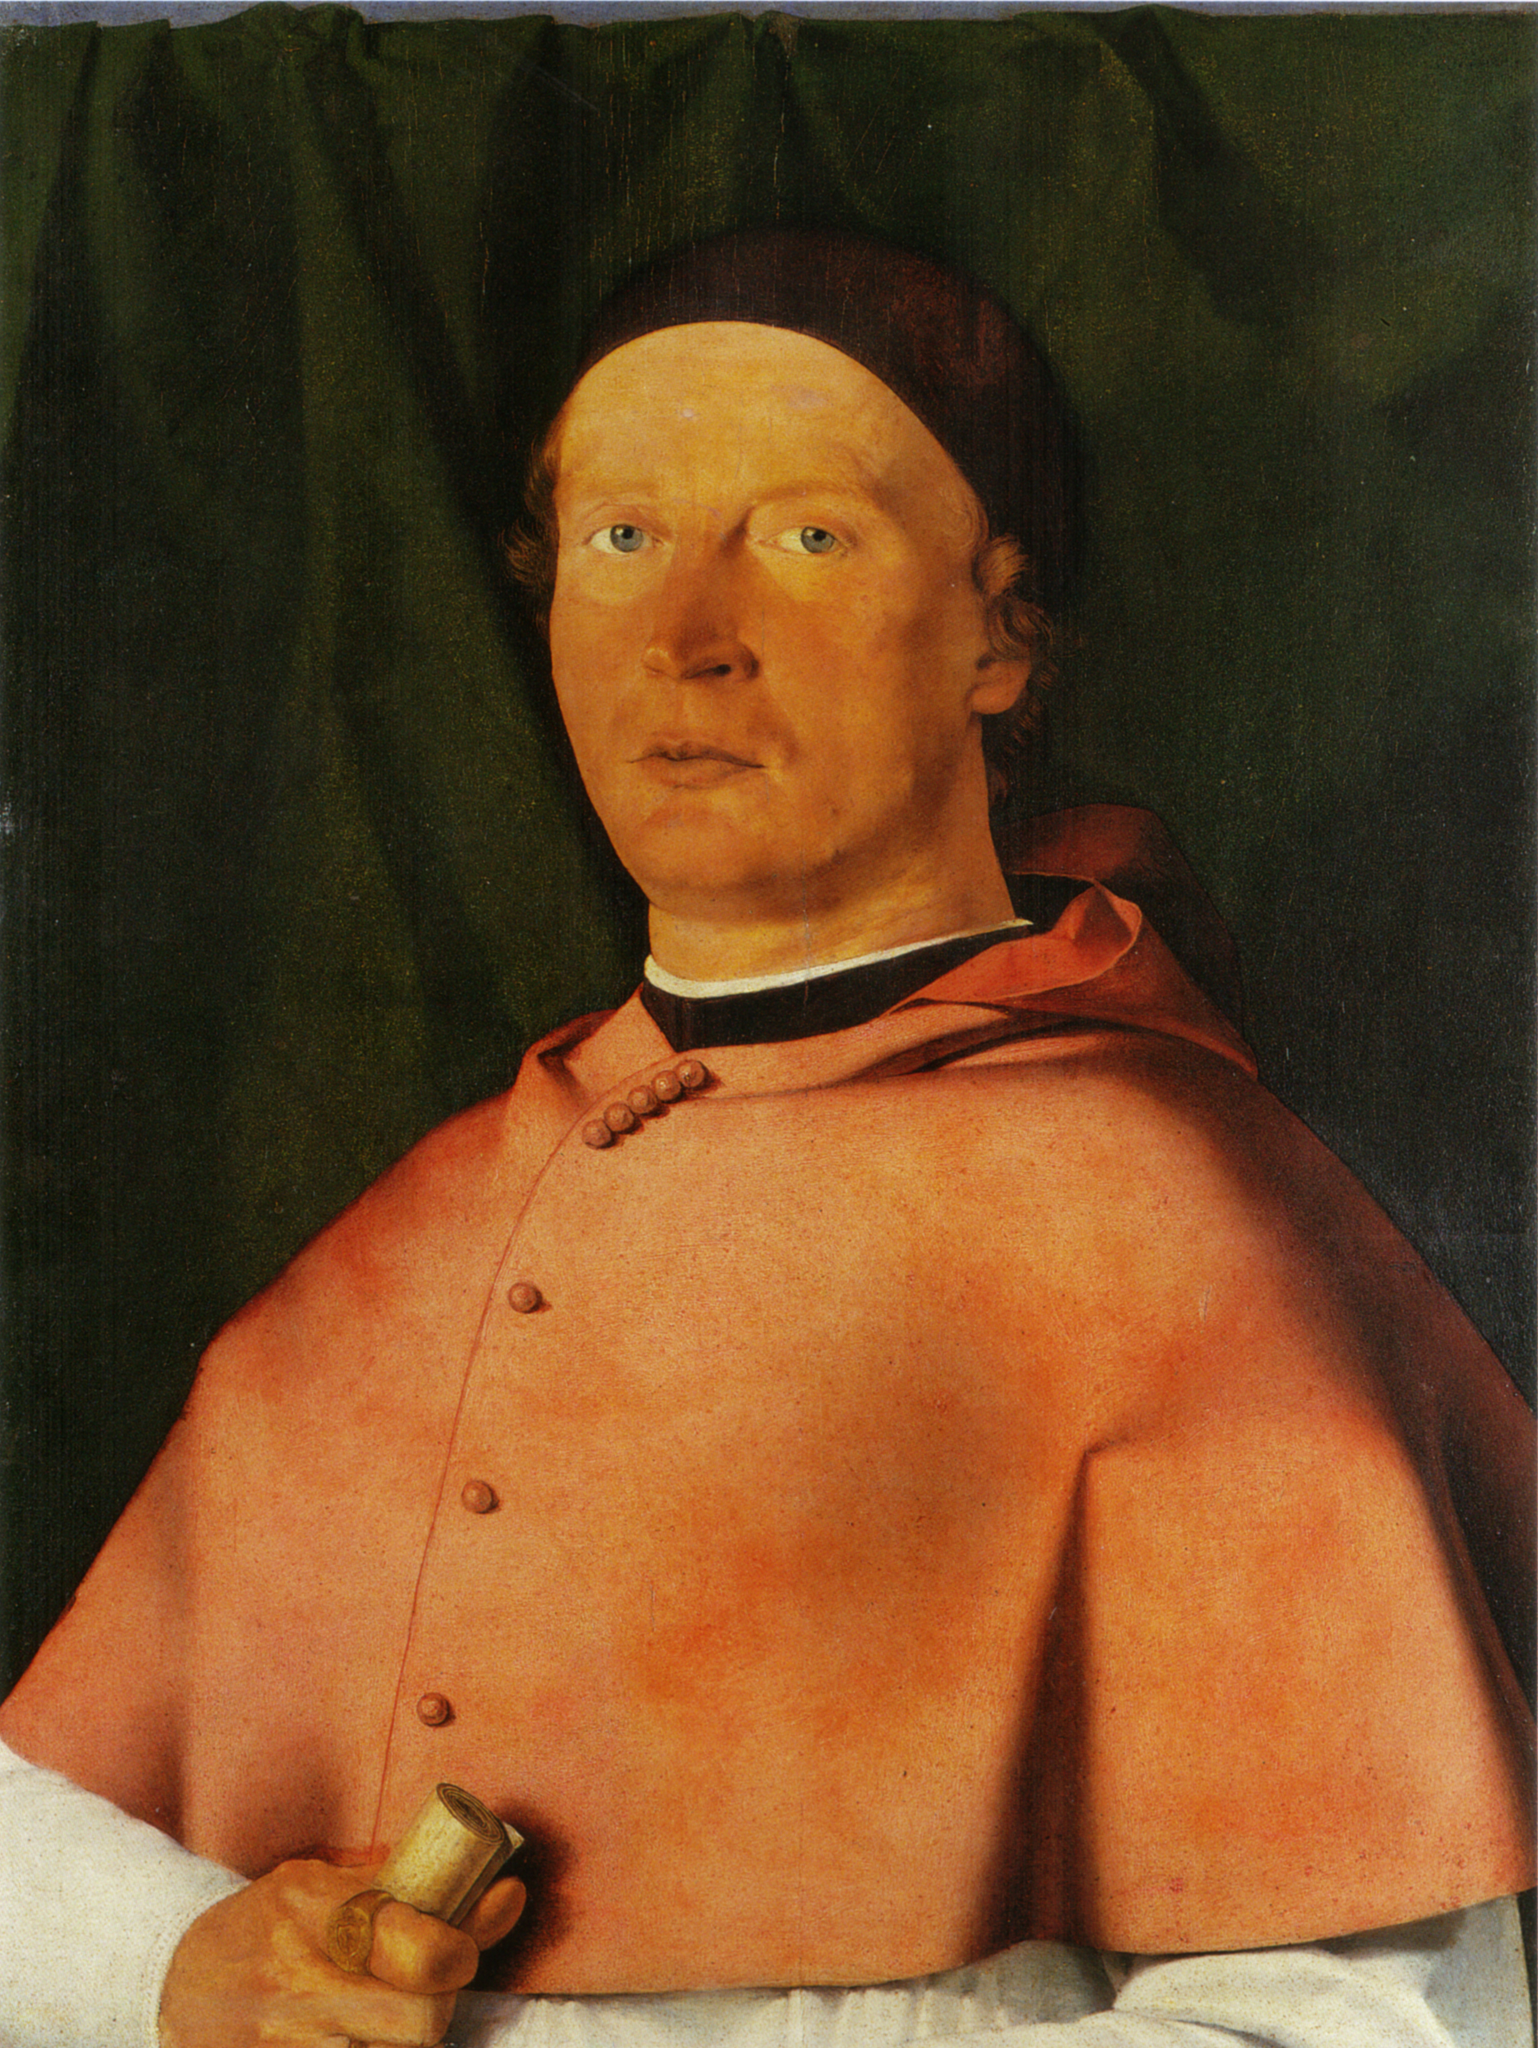What do you think is going on in this snapshot? The image shows a detailed portrait of a man, likely of significant social stature given his attire. He wears a vivid red robe and a black cap, holding a small rolled-up paper or document, possibly indicating his occupation or status. The dark green curtain in the background provides a strong contrast to his clothing. The painting, likely done in oil on panel, showcases the artist’s skill in using light, shadow, and color to create depth and realism. The man’s calm expression and attention to his attire suggest a sense of importance and status, while the document he holds may symbolize his involvement in academic, religious, or governmental affairs. 